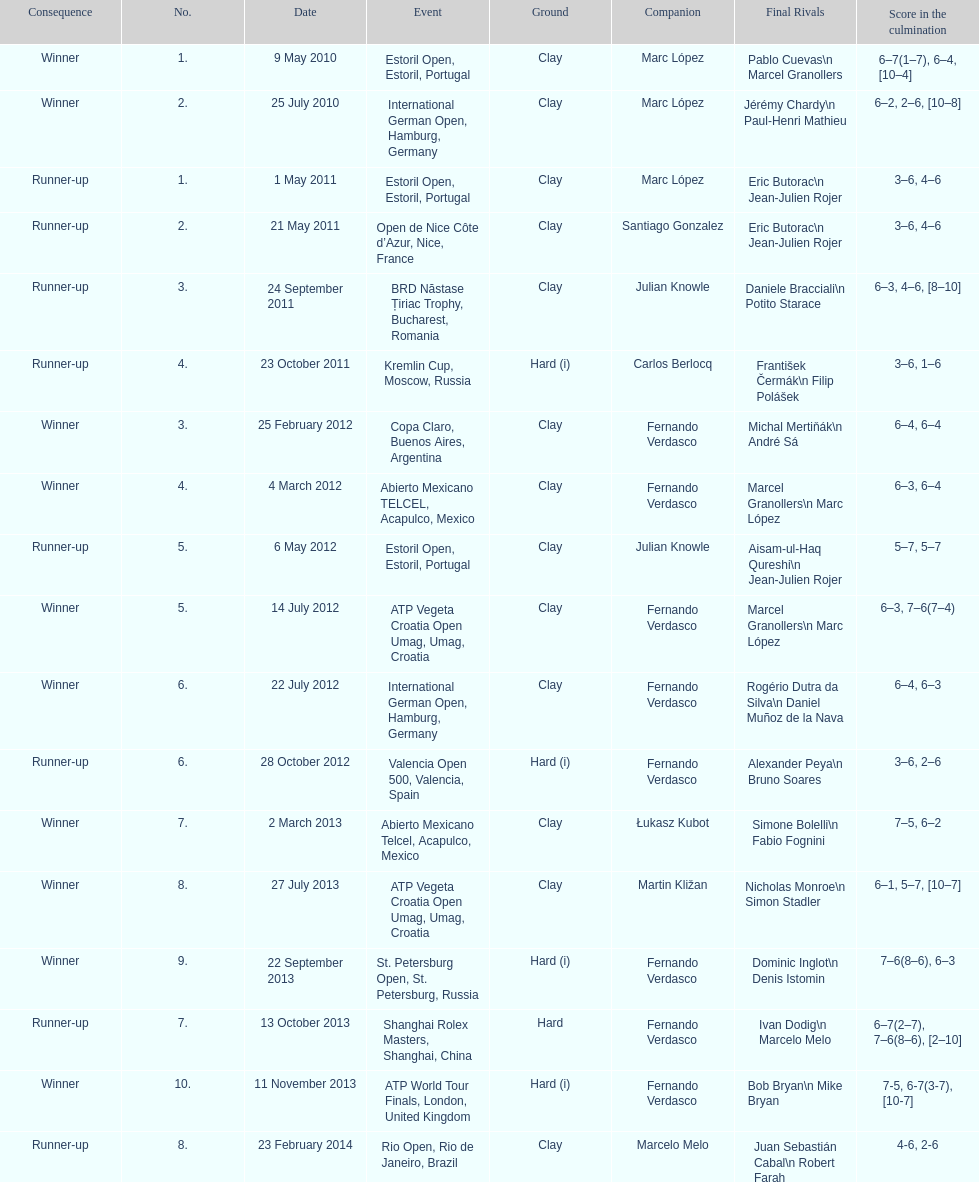What is the total number of runner-ups listed on the chart? 8. 